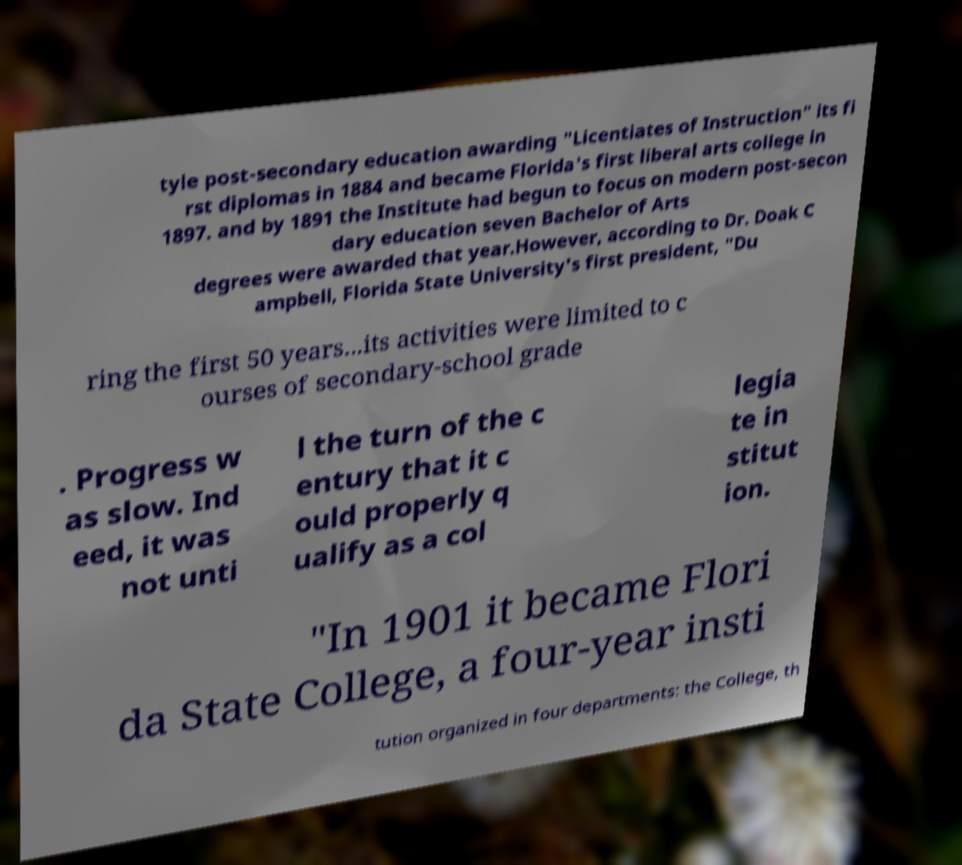Could you assist in decoding the text presented in this image and type it out clearly? tyle post-secondary education awarding "Licentiates of Instruction" its fi rst diplomas in 1884 and became Florida's first liberal arts college in 1897. and by 1891 the Institute had begun to focus on modern post-secon dary education seven Bachelor of Arts degrees were awarded that year.However, according to Dr. Doak C ampbell, Florida State University's first president, "Du ring the first 50 years...its activities were limited to c ourses of secondary-school grade . Progress w as slow. Ind eed, it was not unti l the turn of the c entury that it c ould properly q ualify as a col legia te in stitut ion. "In 1901 it became Flori da State College, a four-year insti tution organized in four departments: the College, th 